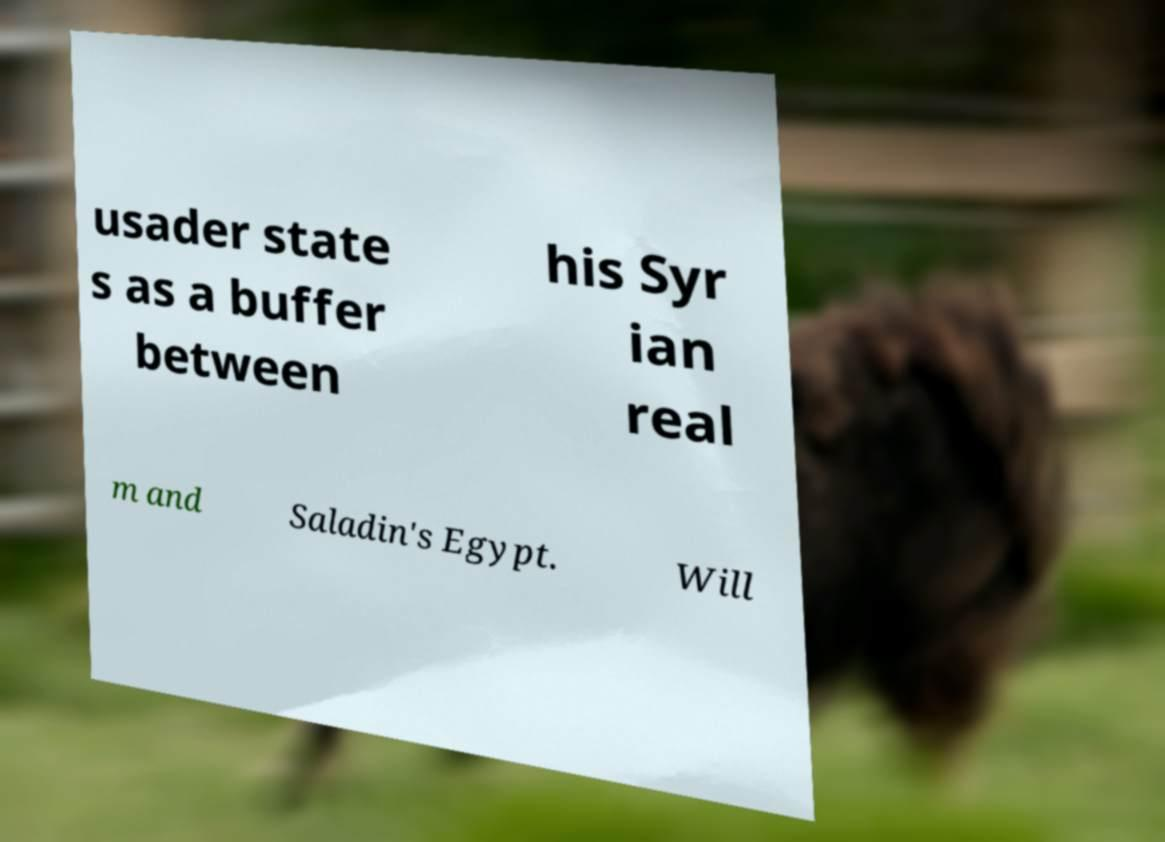Can you read and provide the text displayed in the image?This photo seems to have some interesting text. Can you extract and type it out for me? usader state s as a buffer between his Syr ian real m and Saladin's Egypt. Will 